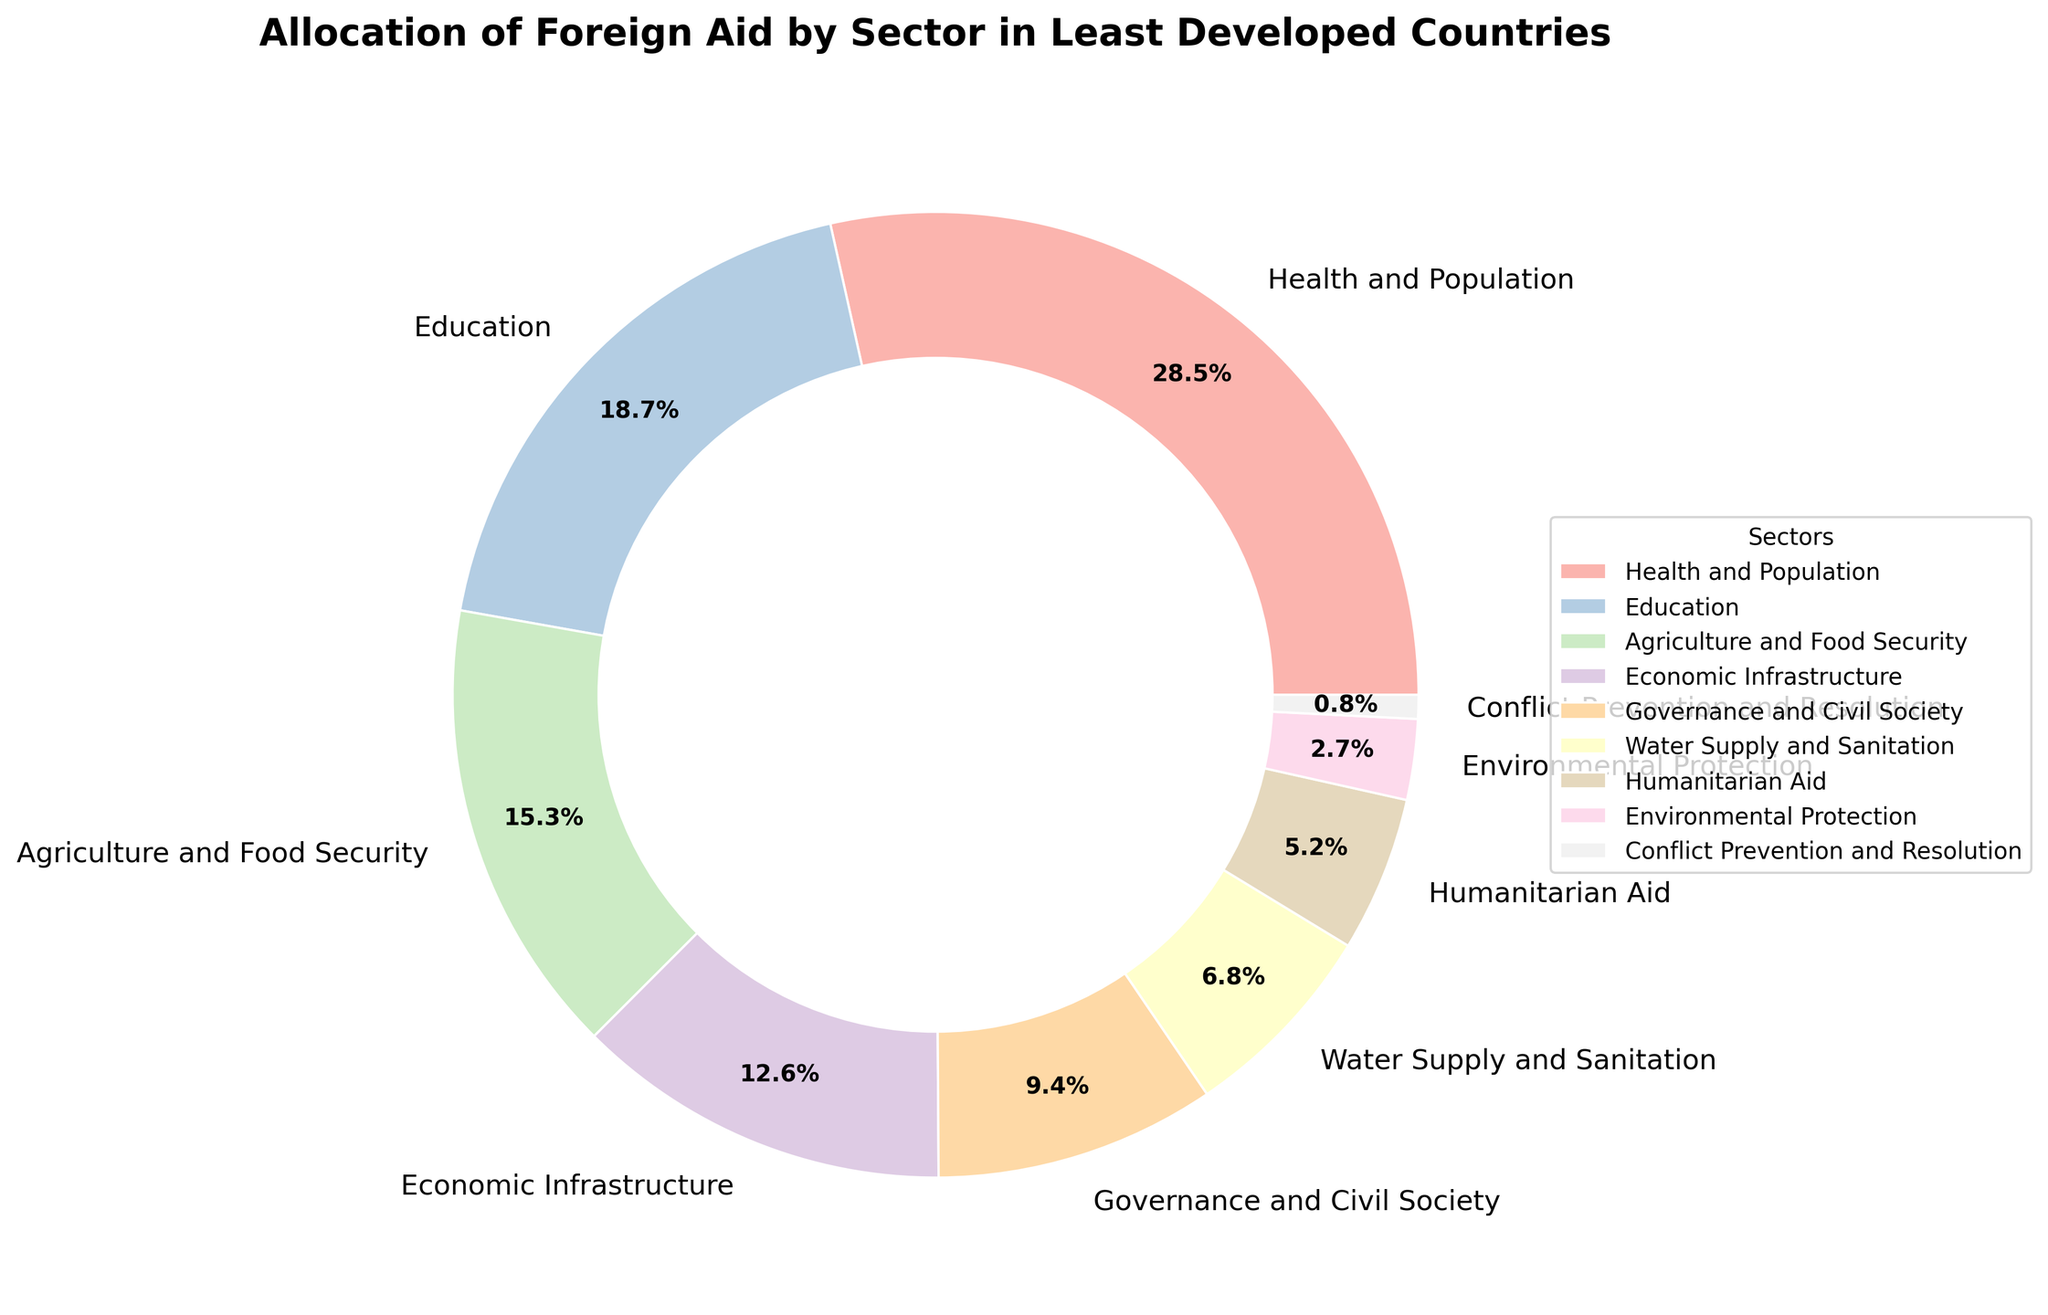Which sector receives the highest allocation of foreign aid? The sector with the largest percentage slice in the pie chart is Health and Population, which is highlighted as 28.5%.
Answer: Health and Population Which sector has the smallest allocation of foreign aid? The sector with the smallest percentage slice in the pie chart is Conflict Prevention and Resolution, highlighted as 0.8%.
Answer: Conflict Prevention and Resolution What is the combined percentage allocation for Agriculture and Food Security and Economic Infrastructure? Add up the percentages for Agriculture and Food Security (15.3%) and Economic Infrastructure (12.6%). 15.3% + 12.6% = 27.9%.
Answer: 27.9% Is the allocation for Education greater or smaller than that for Agriculture and Food Security? Compare the percentage allocation for Education (18.7%) with Agriculture and Food Security (15.3%). Since 18.7% is greater than 15.3%, Education is greater.
Answer: greater How does the allocation for Governance and Civil Society compare to that for Water Supply and Sanitation? Compare the percentage allocation: Governance and Civil Society (9.4%) and Water Supply and Sanitation (6.8%). Governance and Civil Society is greater.
Answer: Governance and Civil Society is greater What is the total percentage allocation for all the sectors combined? Sum up the percentages of all the sectors: 28.5% + 18.7% + 15.3% + 12.6% + 9.4% + 6.8% + 5.2% + 2.7% + 0.8% = 100%.
Answer: 100% What is the difference in percentage allocation between Environmental Protection and Humanitarian Aid? Subtract the percentage for Environmental Protection (2.7%) from Humanitarian Aid (5.2%). 5.2% - 2.7% = 2.5%.
Answer: 2.5% If the allocation for Health and Population was reduced by half, what would its new percentage be? Halve the percentage for Health and Population: 28.5% / 2 = 14.25%.
Answer: 14.25% What percentage of foreign aid allocation goes to sectors other than Health and Population, Education, and Agriculture and Food Security? Subtract the percentages of Health and Population (28.5%), Education (18.7%), and Agriculture and Food Security (15.3%) from the total (100%). 100% - (28.5% + 18.7% + 15.3%) = 37.5%.
Answer: 37.5% Which sectors have allocations greater than 10%? Identify the sectors with more than 10% allocation: Health and Population (28.5%), Education (18.7%), and Agriculture and Food Security (15.3%), and Economic Infrastructure (12.6%).
Answer: Health and Population, Education, Agriculture and Food Security, Economic Infrastructure 